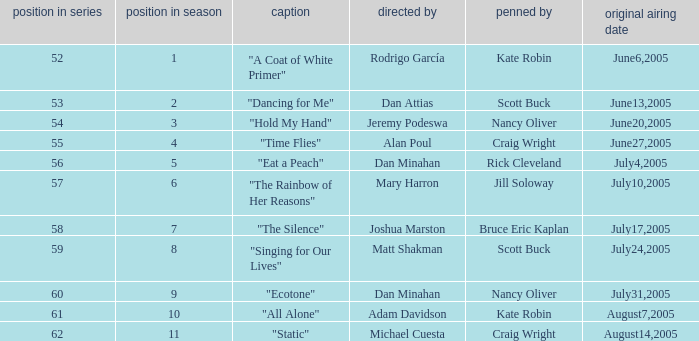What s the episode number in the season that was written by Nancy Oliver? 9.0. 